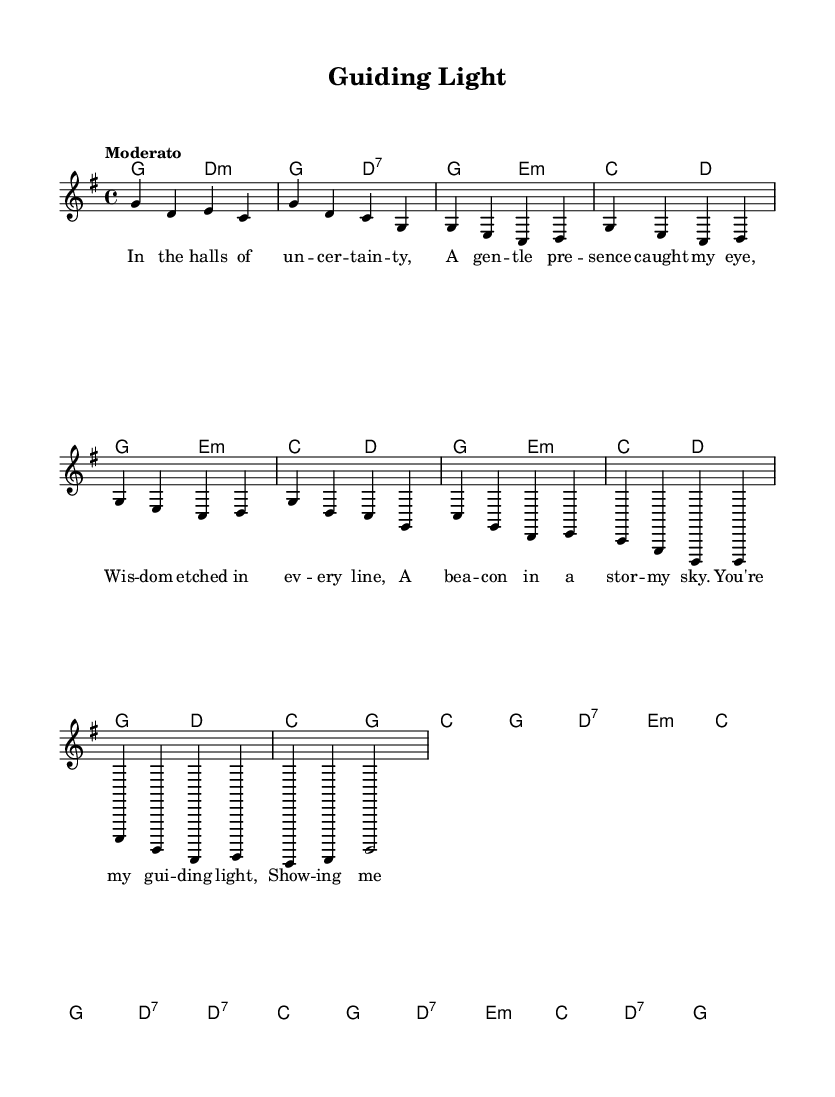What is the key signature of this music? The key signature is G major, indicated by one sharp (F#), which can be determined by looking at the key signature at the beginning of the staff.
Answer: G major What is the time signature of this music? The time signature is four-four, shown as "4/4" at the beginning of the piece, which indicates there are four beats in each measure.
Answer: Four-four What is the tempo marking of the piece? The tempo marking is "Moderato," placed above the staff, indicating a moderate speed ideal for this folk anthem.
Answer: Moderato How many measures are in the chorus section? There are eight measures in the chorus, which can be counted by examining the flow of the music from the beginning of the chorus to its end.
Answer: Eight measures What is the first chord in the song? The first chord is G major, noted at the beginning of the score in the chord section which indicates it is played in the intro.
Answer: G major What lyrical theme does the piece primarily explore? The lyrical theme primarily explores personal growth and self-discovery, as indicated by the text expressing finding guidance through uncertainty and growth.
Answer: Personal growth and self-discovery How many times is the word "guiding" used in the lyrics? The word "guiding" appears once in the chorus, which can be verified by reading through the lyrics carefully.
Answer: Once 